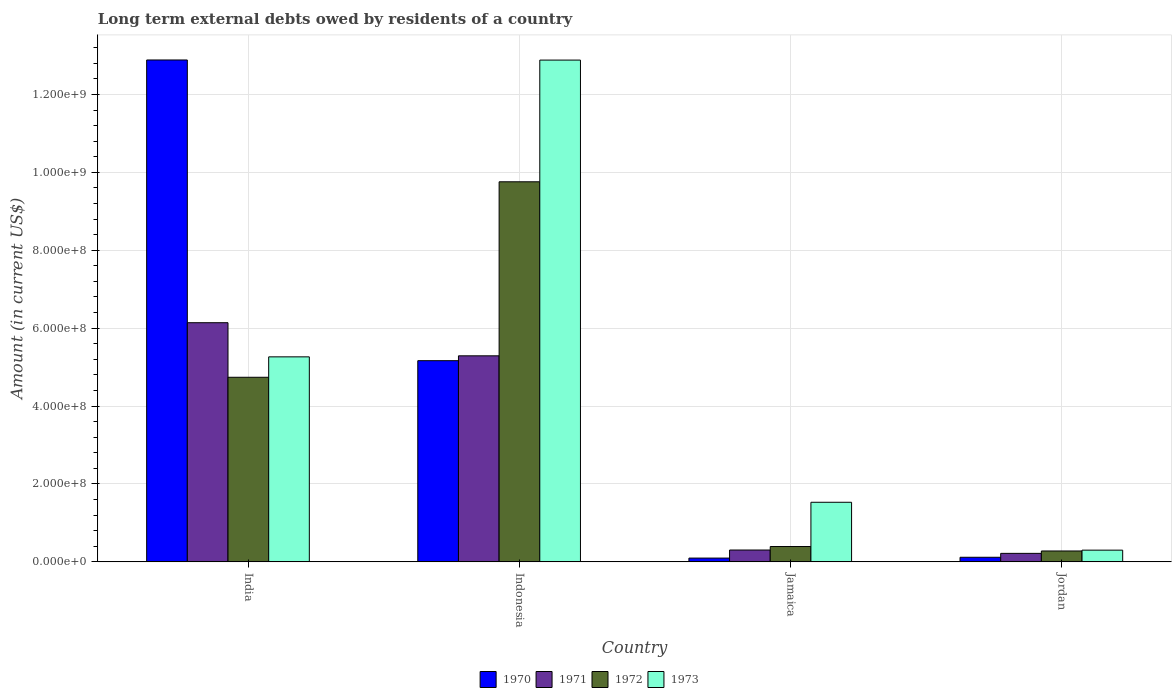How many different coloured bars are there?
Your response must be concise. 4. Are the number of bars on each tick of the X-axis equal?
Your answer should be very brief. Yes. How many bars are there on the 1st tick from the left?
Your answer should be very brief. 4. What is the label of the 4th group of bars from the left?
Your response must be concise. Jordan. What is the amount of long-term external debts owed by residents in 1972 in Jamaica?
Your response must be concise. 3.94e+07. Across all countries, what is the maximum amount of long-term external debts owed by residents in 1971?
Ensure brevity in your answer.  6.14e+08. Across all countries, what is the minimum amount of long-term external debts owed by residents in 1971?
Your answer should be very brief. 2.18e+07. In which country was the amount of long-term external debts owed by residents in 1972 maximum?
Your answer should be compact. Indonesia. In which country was the amount of long-term external debts owed by residents in 1972 minimum?
Keep it short and to the point. Jordan. What is the total amount of long-term external debts owed by residents in 1971 in the graph?
Your answer should be very brief. 1.20e+09. What is the difference between the amount of long-term external debts owed by residents in 1973 in Indonesia and that in Jamaica?
Your answer should be very brief. 1.14e+09. What is the difference between the amount of long-term external debts owed by residents in 1970 in Jamaica and the amount of long-term external debts owed by residents in 1973 in India?
Provide a short and direct response. -5.17e+08. What is the average amount of long-term external debts owed by residents in 1970 per country?
Ensure brevity in your answer.  4.57e+08. What is the difference between the amount of long-term external debts owed by residents of/in 1970 and amount of long-term external debts owed by residents of/in 1971 in Jamaica?
Make the answer very short. -2.07e+07. What is the ratio of the amount of long-term external debts owed by residents in 1972 in India to that in Indonesia?
Offer a very short reply. 0.49. Is the difference between the amount of long-term external debts owed by residents in 1970 in India and Indonesia greater than the difference between the amount of long-term external debts owed by residents in 1971 in India and Indonesia?
Offer a very short reply. Yes. What is the difference between the highest and the second highest amount of long-term external debts owed by residents in 1973?
Offer a terse response. 1.14e+09. What is the difference between the highest and the lowest amount of long-term external debts owed by residents in 1971?
Provide a short and direct response. 5.92e+08. In how many countries, is the amount of long-term external debts owed by residents in 1973 greater than the average amount of long-term external debts owed by residents in 1973 taken over all countries?
Provide a succinct answer. 2. Is the sum of the amount of long-term external debts owed by residents in 1972 in India and Jamaica greater than the maximum amount of long-term external debts owed by residents in 1971 across all countries?
Make the answer very short. No. How many bars are there?
Your answer should be compact. 16. Are the values on the major ticks of Y-axis written in scientific E-notation?
Offer a very short reply. Yes. Where does the legend appear in the graph?
Make the answer very short. Bottom center. What is the title of the graph?
Provide a short and direct response. Long term external debts owed by residents of a country. What is the Amount (in current US$) in 1970 in India?
Ensure brevity in your answer.  1.29e+09. What is the Amount (in current US$) of 1971 in India?
Offer a very short reply. 6.14e+08. What is the Amount (in current US$) of 1972 in India?
Offer a terse response. 4.74e+08. What is the Amount (in current US$) in 1973 in India?
Provide a short and direct response. 5.26e+08. What is the Amount (in current US$) in 1970 in Indonesia?
Offer a very short reply. 5.17e+08. What is the Amount (in current US$) of 1971 in Indonesia?
Ensure brevity in your answer.  5.29e+08. What is the Amount (in current US$) of 1972 in Indonesia?
Offer a terse response. 9.76e+08. What is the Amount (in current US$) in 1973 in Indonesia?
Your response must be concise. 1.29e+09. What is the Amount (in current US$) in 1970 in Jamaica?
Keep it short and to the point. 9.74e+06. What is the Amount (in current US$) in 1971 in Jamaica?
Your answer should be compact. 3.04e+07. What is the Amount (in current US$) in 1972 in Jamaica?
Ensure brevity in your answer.  3.94e+07. What is the Amount (in current US$) in 1973 in Jamaica?
Keep it short and to the point. 1.53e+08. What is the Amount (in current US$) in 1970 in Jordan?
Your response must be concise. 1.18e+07. What is the Amount (in current US$) of 1971 in Jordan?
Make the answer very short. 2.18e+07. What is the Amount (in current US$) in 1972 in Jordan?
Offer a very short reply. 2.80e+07. What is the Amount (in current US$) of 1973 in Jordan?
Make the answer very short. 3.01e+07. Across all countries, what is the maximum Amount (in current US$) in 1970?
Offer a terse response. 1.29e+09. Across all countries, what is the maximum Amount (in current US$) in 1971?
Your answer should be very brief. 6.14e+08. Across all countries, what is the maximum Amount (in current US$) in 1972?
Your answer should be compact. 9.76e+08. Across all countries, what is the maximum Amount (in current US$) in 1973?
Keep it short and to the point. 1.29e+09. Across all countries, what is the minimum Amount (in current US$) in 1970?
Give a very brief answer. 9.74e+06. Across all countries, what is the minimum Amount (in current US$) in 1971?
Keep it short and to the point. 2.18e+07. Across all countries, what is the minimum Amount (in current US$) of 1972?
Provide a succinct answer. 2.80e+07. Across all countries, what is the minimum Amount (in current US$) of 1973?
Your answer should be compact. 3.01e+07. What is the total Amount (in current US$) of 1970 in the graph?
Your answer should be compact. 1.83e+09. What is the total Amount (in current US$) of 1971 in the graph?
Give a very brief answer. 1.20e+09. What is the total Amount (in current US$) of 1972 in the graph?
Your answer should be very brief. 1.52e+09. What is the total Amount (in current US$) of 1973 in the graph?
Provide a short and direct response. 2.00e+09. What is the difference between the Amount (in current US$) in 1970 in India and that in Indonesia?
Your answer should be very brief. 7.72e+08. What is the difference between the Amount (in current US$) in 1971 in India and that in Indonesia?
Provide a short and direct response. 8.50e+07. What is the difference between the Amount (in current US$) in 1972 in India and that in Indonesia?
Your response must be concise. -5.02e+08. What is the difference between the Amount (in current US$) in 1973 in India and that in Indonesia?
Offer a terse response. -7.62e+08. What is the difference between the Amount (in current US$) in 1970 in India and that in Jamaica?
Ensure brevity in your answer.  1.28e+09. What is the difference between the Amount (in current US$) in 1971 in India and that in Jamaica?
Your answer should be compact. 5.84e+08. What is the difference between the Amount (in current US$) of 1972 in India and that in Jamaica?
Your answer should be compact. 4.34e+08. What is the difference between the Amount (in current US$) in 1973 in India and that in Jamaica?
Offer a terse response. 3.73e+08. What is the difference between the Amount (in current US$) in 1970 in India and that in Jordan?
Your answer should be very brief. 1.28e+09. What is the difference between the Amount (in current US$) of 1971 in India and that in Jordan?
Provide a short and direct response. 5.92e+08. What is the difference between the Amount (in current US$) of 1972 in India and that in Jordan?
Ensure brevity in your answer.  4.46e+08. What is the difference between the Amount (in current US$) of 1973 in India and that in Jordan?
Your response must be concise. 4.96e+08. What is the difference between the Amount (in current US$) of 1970 in Indonesia and that in Jamaica?
Your response must be concise. 5.07e+08. What is the difference between the Amount (in current US$) of 1971 in Indonesia and that in Jamaica?
Offer a terse response. 4.99e+08. What is the difference between the Amount (in current US$) in 1972 in Indonesia and that in Jamaica?
Ensure brevity in your answer.  9.36e+08. What is the difference between the Amount (in current US$) of 1973 in Indonesia and that in Jamaica?
Offer a very short reply. 1.14e+09. What is the difference between the Amount (in current US$) of 1970 in Indonesia and that in Jordan?
Your answer should be compact. 5.05e+08. What is the difference between the Amount (in current US$) in 1971 in Indonesia and that in Jordan?
Ensure brevity in your answer.  5.07e+08. What is the difference between the Amount (in current US$) of 1972 in Indonesia and that in Jordan?
Your answer should be compact. 9.48e+08. What is the difference between the Amount (in current US$) in 1973 in Indonesia and that in Jordan?
Your response must be concise. 1.26e+09. What is the difference between the Amount (in current US$) of 1970 in Jamaica and that in Jordan?
Provide a succinct answer. -2.06e+06. What is the difference between the Amount (in current US$) in 1971 in Jamaica and that in Jordan?
Give a very brief answer. 8.59e+06. What is the difference between the Amount (in current US$) of 1972 in Jamaica and that in Jordan?
Your answer should be very brief. 1.14e+07. What is the difference between the Amount (in current US$) of 1973 in Jamaica and that in Jordan?
Offer a very short reply. 1.23e+08. What is the difference between the Amount (in current US$) of 1970 in India and the Amount (in current US$) of 1971 in Indonesia?
Your answer should be very brief. 7.60e+08. What is the difference between the Amount (in current US$) in 1970 in India and the Amount (in current US$) in 1972 in Indonesia?
Ensure brevity in your answer.  3.13e+08. What is the difference between the Amount (in current US$) of 1970 in India and the Amount (in current US$) of 1973 in Indonesia?
Make the answer very short. 3.01e+05. What is the difference between the Amount (in current US$) in 1971 in India and the Amount (in current US$) in 1972 in Indonesia?
Give a very brief answer. -3.62e+08. What is the difference between the Amount (in current US$) of 1971 in India and the Amount (in current US$) of 1973 in Indonesia?
Provide a short and direct response. -6.74e+08. What is the difference between the Amount (in current US$) in 1972 in India and the Amount (in current US$) in 1973 in Indonesia?
Provide a short and direct response. -8.14e+08. What is the difference between the Amount (in current US$) of 1970 in India and the Amount (in current US$) of 1971 in Jamaica?
Offer a terse response. 1.26e+09. What is the difference between the Amount (in current US$) of 1970 in India and the Amount (in current US$) of 1972 in Jamaica?
Offer a very short reply. 1.25e+09. What is the difference between the Amount (in current US$) in 1970 in India and the Amount (in current US$) in 1973 in Jamaica?
Provide a succinct answer. 1.14e+09. What is the difference between the Amount (in current US$) in 1971 in India and the Amount (in current US$) in 1972 in Jamaica?
Provide a short and direct response. 5.75e+08. What is the difference between the Amount (in current US$) in 1971 in India and the Amount (in current US$) in 1973 in Jamaica?
Provide a short and direct response. 4.61e+08. What is the difference between the Amount (in current US$) of 1972 in India and the Amount (in current US$) of 1973 in Jamaica?
Make the answer very short. 3.21e+08. What is the difference between the Amount (in current US$) of 1970 in India and the Amount (in current US$) of 1971 in Jordan?
Your answer should be very brief. 1.27e+09. What is the difference between the Amount (in current US$) of 1970 in India and the Amount (in current US$) of 1972 in Jordan?
Give a very brief answer. 1.26e+09. What is the difference between the Amount (in current US$) of 1970 in India and the Amount (in current US$) of 1973 in Jordan?
Offer a terse response. 1.26e+09. What is the difference between the Amount (in current US$) in 1971 in India and the Amount (in current US$) in 1972 in Jordan?
Keep it short and to the point. 5.86e+08. What is the difference between the Amount (in current US$) in 1971 in India and the Amount (in current US$) in 1973 in Jordan?
Offer a terse response. 5.84e+08. What is the difference between the Amount (in current US$) of 1972 in India and the Amount (in current US$) of 1973 in Jordan?
Your answer should be very brief. 4.44e+08. What is the difference between the Amount (in current US$) of 1970 in Indonesia and the Amount (in current US$) of 1971 in Jamaica?
Offer a terse response. 4.86e+08. What is the difference between the Amount (in current US$) in 1970 in Indonesia and the Amount (in current US$) in 1972 in Jamaica?
Your answer should be very brief. 4.77e+08. What is the difference between the Amount (in current US$) in 1970 in Indonesia and the Amount (in current US$) in 1973 in Jamaica?
Make the answer very short. 3.64e+08. What is the difference between the Amount (in current US$) of 1971 in Indonesia and the Amount (in current US$) of 1972 in Jamaica?
Your response must be concise. 4.90e+08. What is the difference between the Amount (in current US$) in 1971 in Indonesia and the Amount (in current US$) in 1973 in Jamaica?
Provide a short and direct response. 3.76e+08. What is the difference between the Amount (in current US$) of 1972 in Indonesia and the Amount (in current US$) of 1973 in Jamaica?
Keep it short and to the point. 8.23e+08. What is the difference between the Amount (in current US$) in 1970 in Indonesia and the Amount (in current US$) in 1971 in Jordan?
Give a very brief answer. 4.95e+08. What is the difference between the Amount (in current US$) of 1970 in Indonesia and the Amount (in current US$) of 1972 in Jordan?
Your response must be concise. 4.89e+08. What is the difference between the Amount (in current US$) of 1970 in Indonesia and the Amount (in current US$) of 1973 in Jordan?
Your answer should be very brief. 4.86e+08. What is the difference between the Amount (in current US$) in 1971 in Indonesia and the Amount (in current US$) in 1972 in Jordan?
Make the answer very short. 5.01e+08. What is the difference between the Amount (in current US$) in 1971 in Indonesia and the Amount (in current US$) in 1973 in Jordan?
Make the answer very short. 4.99e+08. What is the difference between the Amount (in current US$) in 1972 in Indonesia and the Amount (in current US$) in 1973 in Jordan?
Your response must be concise. 9.46e+08. What is the difference between the Amount (in current US$) in 1970 in Jamaica and the Amount (in current US$) in 1971 in Jordan?
Your answer should be compact. -1.21e+07. What is the difference between the Amount (in current US$) in 1970 in Jamaica and the Amount (in current US$) in 1972 in Jordan?
Your answer should be very brief. -1.82e+07. What is the difference between the Amount (in current US$) in 1970 in Jamaica and the Amount (in current US$) in 1973 in Jordan?
Provide a succinct answer. -2.04e+07. What is the difference between the Amount (in current US$) of 1971 in Jamaica and the Amount (in current US$) of 1972 in Jordan?
Offer a terse response. 2.46e+06. What is the difference between the Amount (in current US$) of 1971 in Jamaica and the Amount (in current US$) of 1973 in Jordan?
Offer a very short reply. 3.43e+05. What is the difference between the Amount (in current US$) in 1972 in Jamaica and the Amount (in current US$) in 1973 in Jordan?
Your answer should be very brief. 9.32e+06. What is the average Amount (in current US$) of 1970 per country?
Provide a succinct answer. 4.57e+08. What is the average Amount (in current US$) in 1971 per country?
Your answer should be very brief. 2.99e+08. What is the average Amount (in current US$) in 1972 per country?
Provide a succinct answer. 3.79e+08. What is the average Amount (in current US$) of 1973 per country?
Your response must be concise. 4.99e+08. What is the difference between the Amount (in current US$) of 1970 and Amount (in current US$) of 1971 in India?
Ensure brevity in your answer.  6.74e+08. What is the difference between the Amount (in current US$) in 1970 and Amount (in current US$) in 1972 in India?
Your response must be concise. 8.15e+08. What is the difference between the Amount (in current US$) in 1970 and Amount (in current US$) in 1973 in India?
Provide a succinct answer. 7.62e+08. What is the difference between the Amount (in current US$) in 1971 and Amount (in current US$) in 1972 in India?
Offer a terse response. 1.40e+08. What is the difference between the Amount (in current US$) in 1971 and Amount (in current US$) in 1973 in India?
Your answer should be very brief. 8.77e+07. What is the difference between the Amount (in current US$) of 1972 and Amount (in current US$) of 1973 in India?
Your response must be concise. -5.24e+07. What is the difference between the Amount (in current US$) of 1970 and Amount (in current US$) of 1971 in Indonesia?
Make the answer very short. -1.25e+07. What is the difference between the Amount (in current US$) of 1970 and Amount (in current US$) of 1972 in Indonesia?
Your answer should be compact. -4.59e+08. What is the difference between the Amount (in current US$) in 1970 and Amount (in current US$) in 1973 in Indonesia?
Your response must be concise. -7.72e+08. What is the difference between the Amount (in current US$) of 1971 and Amount (in current US$) of 1972 in Indonesia?
Make the answer very short. -4.47e+08. What is the difference between the Amount (in current US$) of 1971 and Amount (in current US$) of 1973 in Indonesia?
Give a very brief answer. -7.59e+08. What is the difference between the Amount (in current US$) of 1972 and Amount (in current US$) of 1973 in Indonesia?
Keep it short and to the point. -3.12e+08. What is the difference between the Amount (in current US$) of 1970 and Amount (in current US$) of 1971 in Jamaica?
Make the answer very short. -2.07e+07. What is the difference between the Amount (in current US$) of 1970 and Amount (in current US$) of 1972 in Jamaica?
Make the answer very short. -2.97e+07. What is the difference between the Amount (in current US$) in 1970 and Amount (in current US$) in 1973 in Jamaica?
Provide a short and direct response. -1.43e+08. What is the difference between the Amount (in current US$) of 1971 and Amount (in current US$) of 1972 in Jamaica?
Ensure brevity in your answer.  -8.97e+06. What is the difference between the Amount (in current US$) of 1971 and Amount (in current US$) of 1973 in Jamaica?
Keep it short and to the point. -1.23e+08. What is the difference between the Amount (in current US$) of 1972 and Amount (in current US$) of 1973 in Jamaica?
Make the answer very short. -1.14e+08. What is the difference between the Amount (in current US$) in 1970 and Amount (in current US$) in 1971 in Jordan?
Offer a very short reply. -1.00e+07. What is the difference between the Amount (in current US$) in 1970 and Amount (in current US$) in 1972 in Jordan?
Provide a short and direct response. -1.62e+07. What is the difference between the Amount (in current US$) in 1970 and Amount (in current US$) in 1973 in Jordan?
Ensure brevity in your answer.  -1.83e+07. What is the difference between the Amount (in current US$) in 1971 and Amount (in current US$) in 1972 in Jordan?
Give a very brief answer. -6.12e+06. What is the difference between the Amount (in current US$) of 1971 and Amount (in current US$) of 1973 in Jordan?
Offer a very short reply. -8.24e+06. What is the difference between the Amount (in current US$) in 1972 and Amount (in current US$) in 1973 in Jordan?
Your response must be concise. -2.12e+06. What is the ratio of the Amount (in current US$) of 1970 in India to that in Indonesia?
Your answer should be compact. 2.49. What is the ratio of the Amount (in current US$) of 1971 in India to that in Indonesia?
Offer a terse response. 1.16. What is the ratio of the Amount (in current US$) of 1972 in India to that in Indonesia?
Make the answer very short. 0.49. What is the ratio of the Amount (in current US$) of 1973 in India to that in Indonesia?
Your answer should be very brief. 0.41. What is the ratio of the Amount (in current US$) in 1970 in India to that in Jamaica?
Give a very brief answer. 132.34. What is the ratio of the Amount (in current US$) of 1971 in India to that in Jamaica?
Offer a terse response. 20.18. What is the ratio of the Amount (in current US$) of 1972 in India to that in Jamaica?
Provide a short and direct response. 12.03. What is the ratio of the Amount (in current US$) of 1973 in India to that in Jamaica?
Keep it short and to the point. 3.44. What is the ratio of the Amount (in current US$) in 1970 in India to that in Jordan?
Your answer should be very brief. 109.2. What is the ratio of the Amount (in current US$) in 1971 in India to that in Jordan?
Your response must be concise. 28.11. What is the ratio of the Amount (in current US$) of 1972 in India to that in Jordan?
Your answer should be compact. 16.95. What is the ratio of the Amount (in current US$) in 1973 in India to that in Jordan?
Your answer should be compact. 17.49. What is the ratio of the Amount (in current US$) of 1970 in Indonesia to that in Jamaica?
Make the answer very short. 53.05. What is the ratio of the Amount (in current US$) in 1971 in Indonesia to that in Jamaica?
Keep it short and to the point. 17.38. What is the ratio of the Amount (in current US$) in 1972 in Indonesia to that in Jamaica?
Provide a succinct answer. 24.76. What is the ratio of the Amount (in current US$) of 1973 in Indonesia to that in Jamaica?
Give a very brief answer. 8.42. What is the ratio of the Amount (in current US$) of 1970 in Indonesia to that in Jordan?
Offer a very short reply. 43.77. What is the ratio of the Amount (in current US$) of 1971 in Indonesia to that in Jordan?
Keep it short and to the point. 24.22. What is the ratio of the Amount (in current US$) in 1972 in Indonesia to that in Jordan?
Give a very brief answer. 34.89. What is the ratio of the Amount (in current US$) of 1973 in Indonesia to that in Jordan?
Your answer should be compact. 42.81. What is the ratio of the Amount (in current US$) of 1970 in Jamaica to that in Jordan?
Your answer should be compact. 0.83. What is the ratio of the Amount (in current US$) of 1971 in Jamaica to that in Jordan?
Your response must be concise. 1.39. What is the ratio of the Amount (in current US$) in 1972 in Jamaica to that in Jordan?
Provide a short and direct response. 1.41. What is the ratio of the Amount (in current US$) of 1973 in Jamaica to that in Jordan?
Offer a terse response. 5.08. What is the difference between the highest and the second highest Amount (in current US$) of 1970?
Your answer should be compact. 7.72e+08. What is the difference between the highest and the second highest Amount (in current US$) in 1971?
Offer a terse response. 8.50e+07. What is the difference between the highest and the second highest Amount (in current US$) of 1972?
Your answer should be very brief. 5.02e+08. What is the difference between the highest and the second highest Amount (in current US$) of 1973?
Your answer should be very brief. 7.62e+08. What is the difference between the highest and the lowest Amount (in current US$) of 1970?
Your answer should be compact. 1.28e+09. What is the difference between the highest and the lowest Amount (in current US$) in 1971?
Offer a very short reply. 5.92e+08. What is the difference between the highest and the lowest Amount (in current US$) in 1972?
Your response must be concise. 9.48e+08. What is the difference between the highest and the lowest Amount (in current US$) in 1973?
Your answer should be compact. 1.26e+09. 